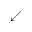<formula> <loc_0><loc_0><loc_500><loc_500>\swarrow</formula> 